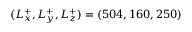Convert formula to latex. <formula><loc_0><loc_0><loc_500><loc_500>( L _ { x } ^ { + } , L _ { y } ^ { + } , L _ { z } ^ { + } ) = ( 5 0 4 , 1 6 0 , 2 5 0 )</formula> 